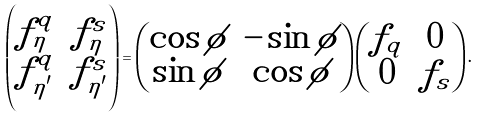<formula> <loc_0><loc_0><loc_500><loc_500>\begin{pmatrix} f _ { \eta } ^ { q } & f _ { \eta } ^ { s } \\ f _ { \eta ^ { \prime } } ^ { q } & f _ { \eta ^ { \prime } } ^ { s } \end{pmatrix} = \begin{pmatrix} \cos \phi & - \sin \phi \\ \sin \phi & \cos \phi \end{pmatrix} \begin{pmatrix} f _ { q } & 0 \\ 0 & f _ { s } \end{pmatrix} .</formula> 